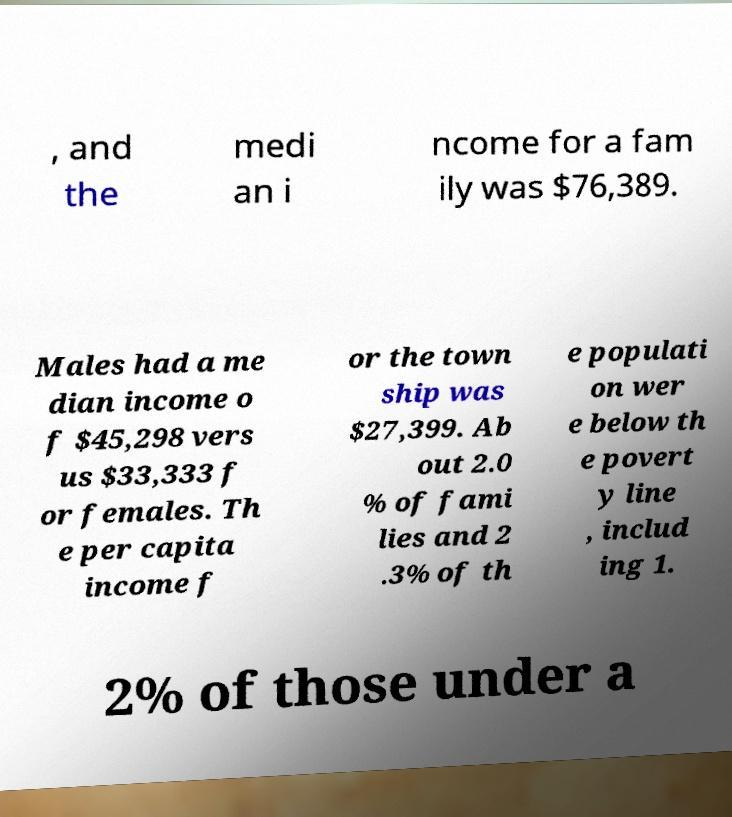For documentation purposes, I need the text within this image transcribed. Could you provide that? , and the medi an i ncome for a fam ily was $76,389. Males had a me dian income o f $45,298 vers us $33,333 f or females. Th e per capita income f or the town ship was $27,399. Ab out 2.0 % of fami lies and 2 .3% of th e populati on wer e below th e povert y line , includ ing 1. 2% of those under a 